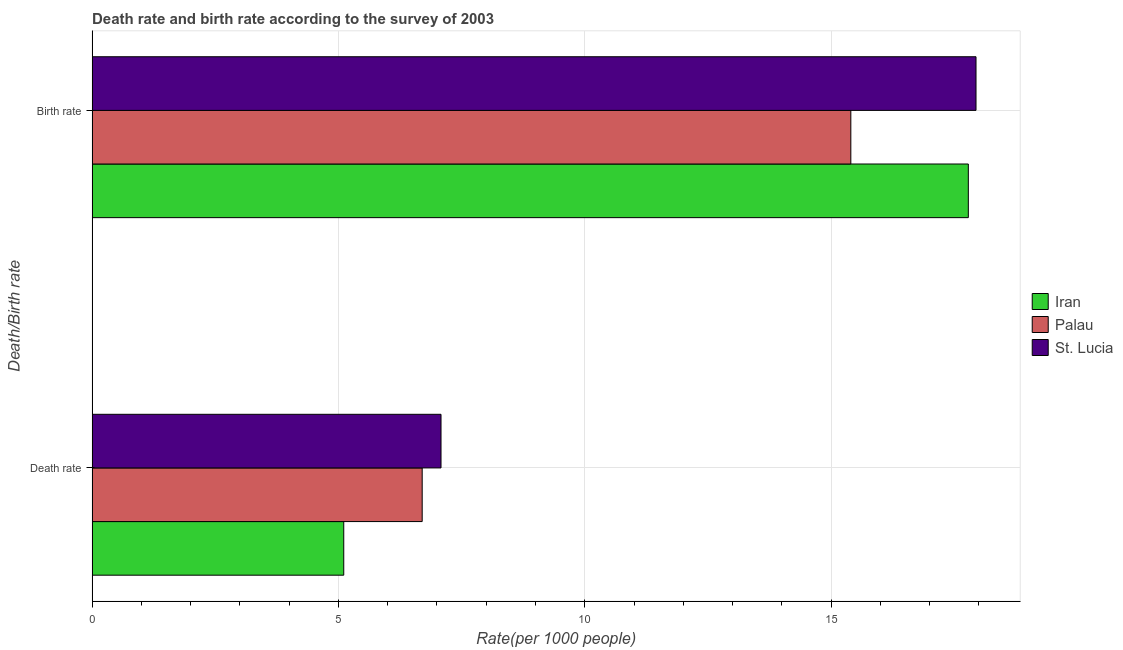How many bars are there on the 1st tick from the top?
Your response must be concise. 3. How many bars are there on the 1st tick from the bottom?
Ensure brevity in your answer.  3. What is the label of the 2nd group of bars from the top?
Offer a terse response. Death rate. What is the death rate in Iran?
Offer a very short reply. 5.11. Across all countries, what is the maximum death rate?
Provide a succinct answer. 7.08. Across all countries, what is the minimum death rate?
Make the answer very short. 5.11. In which country was the death rate maximum?
Your answer should be very brief. St. Lucia. In which country was the birth rate minimum?
Give a very brief answer. Palau. What is the total birth rate in the graph?
Keep it short and to the point. 51.13. What is the difference between the death rate in Palau and that in Iran?
Your response must be concise. 1.59. What is the difference between the birth rate in Palau and the death rate in Iran?
Provide a succinct answer. 10.29. What is the average death rate per country?
Provide a succinct answer. 6.3. What is the difference between the death rate and birth rate in Iran?
Provide a succinct answer. -12.68. What is the ratio of the birth rate in Iran to that in Palau?
Your answer should be compact. 1.15. Is the birth rate in Palau less than that in St. Lucia?
Keep it short and to the point. Yes. In how many countries, is the death rate greater than the average death rate taken over all countries?
Your answer should be very brief. 2. What does the 2nd bar from the top in Death rate represents?
Ensure brevity in your answer.  Palau. What does the 3rd bar from the bottom in Birth rate represents?
Offer a very short reply. St. Lucia. Are the values on the major ticks of X-axis written in scientific E-notation?
Your answer should be compact. No. Where does the legend appear in the graph?
Your answer should be very brief. Center right. How are the legend labels stacked?
Keep it short and to the point. Vertical. What is the title of the graph?
Keep it short and to the point. Death rate and birth rate according to the survey of 2003. What is the label or title of the X-axis?
Your answer should be very brief. Rate(per 1000 people). What is the label or title of the Y-axis?
Provide a short and direct response. Death/Birth rate. What is the Rate(per 1000 people) in Iran in Death rate?
Make the answer very short. 5.11. What is the Rate(per 1000 people) of Palau in Death rate?
Your response must be concise. 6.7. What is the Rate(per 1000 people) of St. Lucia in Death rate?
Keep it short and to the point. 7.08. What is the Rate(per 1000 people) of Iran in Birth rate?
Keep it short and to the point. 17.79. What is the Rate(per 1000 people) of Palau in Birth rate?
Your response must be concise. 15.4. What is the Rate(per 1000 people) in St. Lucia in Birth rate?
Offer a very short reply. 17.94. Across all Death/Birth rate, what is the maximum Rate(per 1000 people) of Iran?
Provide a short and direct response. 17.79. Across all Death/Birth rate, what is the maximum Rate(per 1000 people) of Palau?
Offer a terse response. 15.4. Across all Death/Birth rate, what is the maximum Rate(per 1000 people) in St. Lucia?
Your answer should be very brief. 17.94. Across all Death/Birth rate, what is the minimum Rate(per 1000 people) of Iran?
Provide a short and direct response. 5.11. Across all Death/Birth rate, what is the minimum Rate(per 1000 people) of Palau?
Give a very brief answer. 6.7. Across all Death/Birth rate, what is the minimum Rate(per 1000 people) in St. Lucia?
Offer a very short reply. 7.08. What is the total Rate(per 1000 people) of Iran in the graph?
Offer a very short reply. 22.89. What is the total Rate(per 1000 people) of Palau in the graph?
Ensure brevity in your answer.  22.1. What is the total Rate(per 1000 people) in St. Lucia in the graph?
Keep it short and to the point. 25.02. What is the difference between the Rate(per 1000 people) of Iran in Death rate and that in Birth rate?
Keep it short and to the point. -12.68. What is the difference between the Rate(per 1000 people) in Palau in Death rate and that in Birth rate?
Give a very brief answer. -8.7. What is the difference between the Rate(per 1000 people) of St. Lucia in Death rate and that in Birth rate?
Give a very brief answer. -10.86. What is the difference between the Rate(per 1000 people) in Iran in Death rate and the Rate(per 1000 people) in Palau in Birth rate?
Offer a terse response. -10.29. What is the difference between the Rate(per 1000 people) of Iran in Death rate and the Rate(per 1000 people) of St. Lucia in Birth rate?
Your answer should be very brief. -12.83. What is the difference between the Rate(per 1000 people) in Palau in Death rate and the Rate(per 1000 people) in St. Lucia in Birth rate?
Make the answer very short. -11.24. What is the average Rate(per 1000 people) in Iran per Death/Birth rate?
Keep it short and to the point. 11.45. What is the average Rate(per 1000 people) in Palau per Death/Birth rate?
Offer a very short reply. 11.05. What is the average Rate(per 1000 people) in St. Lucia per Death/Birth rate?
Provide a short and direct response. 12.51. What is the difference between the Rate(per 1000 people) of Iran and Rate(per 1000 people) of Palau in Death rate?
Keep it short and to the point. -1.59. What is the difference between the Rate(per 1000 people) in Iran and Rate(per 1000 people) in St. Lucia in Death rate?
Keep it short and to the point. -1.97. What is the difference between the Rate(per 1000 people) in Palau and Rate(per 1000 people) in St. Lucia in Death rate?
Provide a succinct answer. -0.38. What is the difference between the Rate(per 1000 people) in Iran and Rate(per 1000 people) in Palau in Birth rate?
Give a very brief answer. 2.38. What is the difference between the Rate(per 1000 people) of Iran and Rate(per 1000 people) of St. Lucia in Birth rate?
Offer a terse response. -0.16. What is the difference between the Rate(per 1000 people) in Palau and Rate(per 1000 people) in St. Lucia in Birth rate?
Ensure brevity in your answer.  -2.54. What is the ratio of the Rate(per 1000 people) in Iran in Death rate to that in Birth rate?
Your response must be concise. 0.29. What is the ratio of the Rate(per 1000 people) in Palau in Death rate to that in Birth rate?
Make the answer very short. 0.44. What is the ratio of the Rate(per 1000 people) in St. Lucia in Death rate to that in Birth rate?
Offer a terse response. 0.39. What is the difference between the highest and the second highest Rate(per 1000 people) of Iran?
Provide a succinct answer. 12.68. What is the difference between the highest and the second highest Rate(per 1000 people) of Palau?
Offer a terse response. 8.7. What is the difference between the highest and the second highest Rate(per 1000 people) in St. Lucia?
Provide a short and direct response. 10.86. What is the difference between the highest and the lowest Rate(per 1000 people) of Iran?
Keep it short and to the point. 12.68. What is the difference between the highest and the lowest Rate(per 1000 people) in Palau?
Provide a short and direct response. 8.7. What is the difference between the highest and the lowest Rate(per 1000 people) in St. Lucia?
Your answer should be compact. 10.86. 